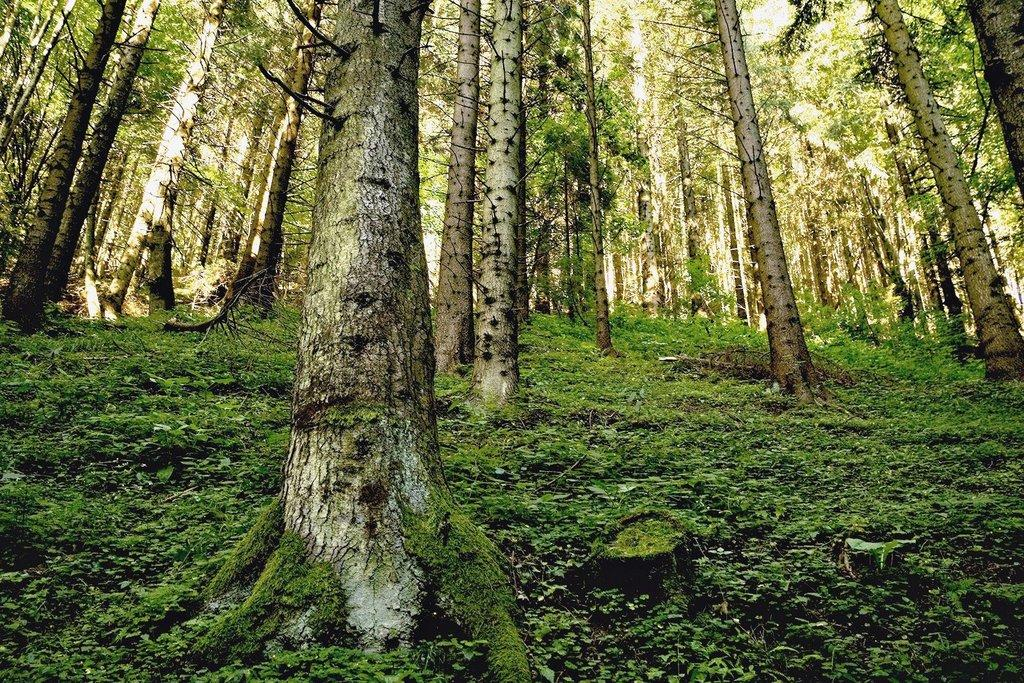What type of vegetation can be seen in the image? There are trees and plants in the image. What covers the ground in the image? There is grass on the ground in the image. How many cars can be seen in the image? There are no cars present in the image; it features trees, plants, and grass. Can you tell me how many knives are being used to touch the trees in the image? There are no knives or any form of touching depicted in the image; it simply shows trees, plants, and grass. 